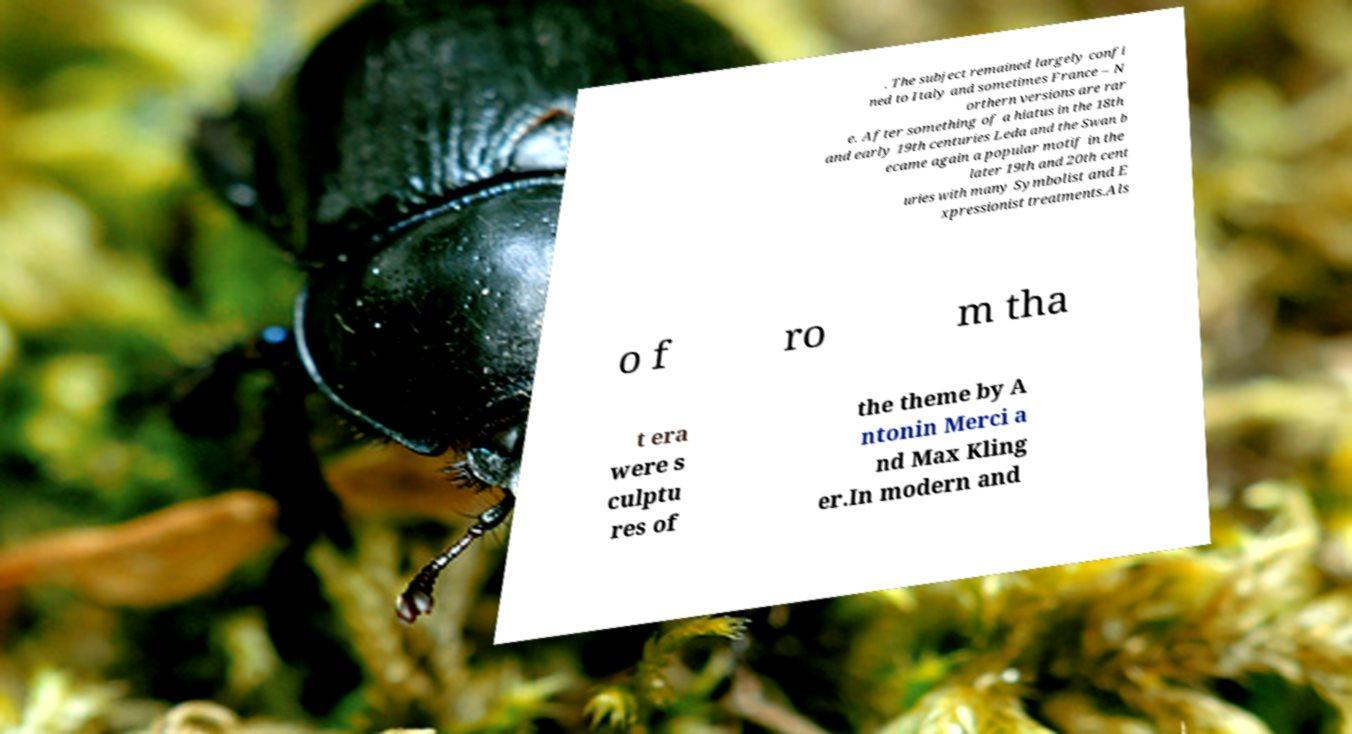Could you assist in decoding the text presented in this image and type it out clearly? . The subject remained largely confi ned to Italy and sometimes France – N orthern versions are rar e. After something of a hiatus in the 18th and early 19th centuries Leda and the Swan b ecame again a popular motif in the later 19th and 20th cent uries with many Symbolist and E xpressionist treatments.Als o f ro m tha t era were s culptu res of the theme by A ntonin Merci a nd Max Kling er.In modern and 